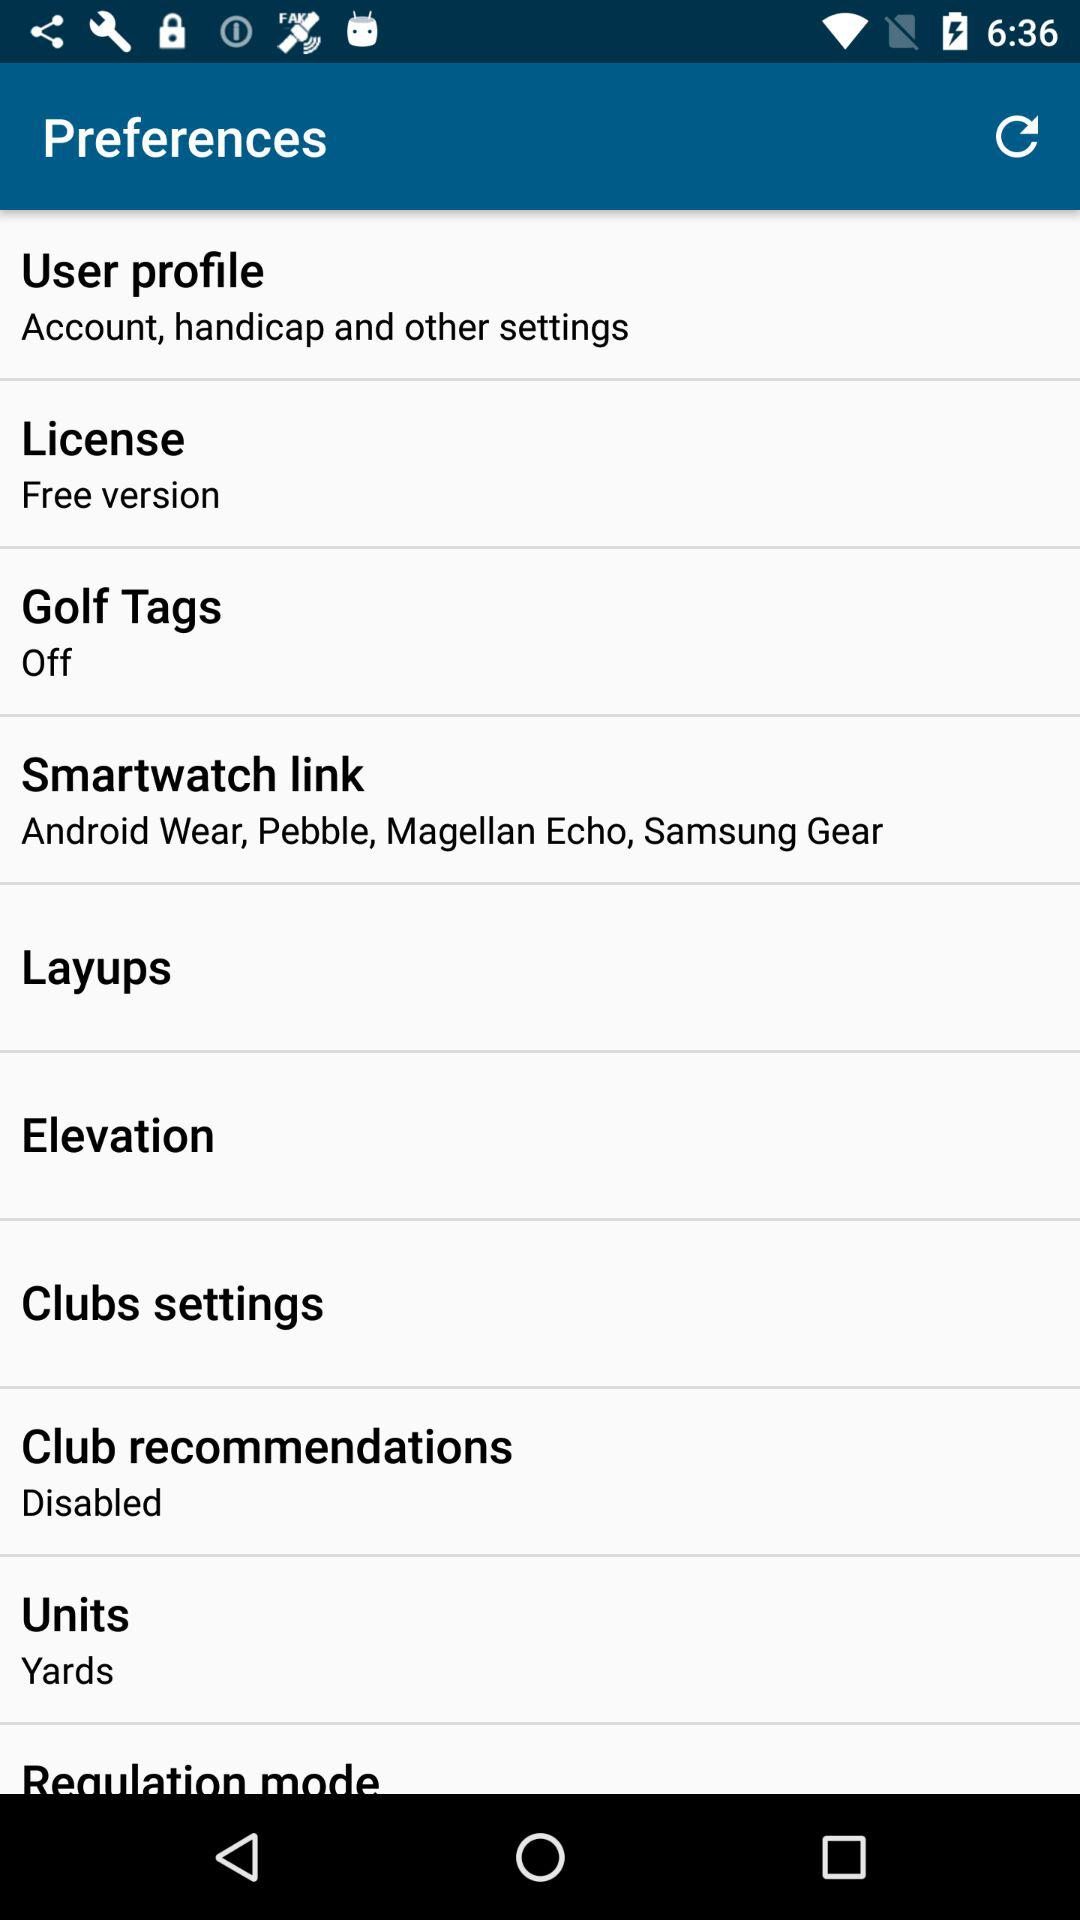What is the status of the golf tags? The status is "off". 